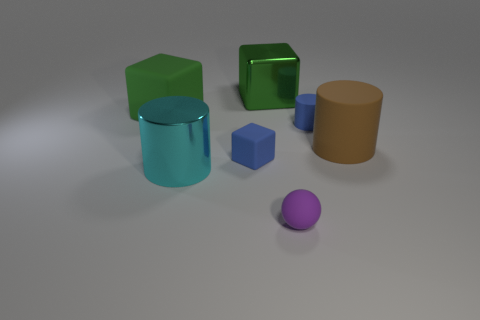Does the small matte block have the same color as the small cylinder?
Keep it short and to the point. Yes. Are there any brown objects of the same shape as the big cyan metal object?
Your answer should be very brief. Yes. How many big gray cubes have the same material as the tiny cube?
Offer a very short reply. 0. Do the object to the right of the blue cylinder and the purple object have the same material?
Your answer should be very brief. Yes. Are there more blocks behind the green matte thing than big green cubes that are right of the purple thing?
Give a very brief answer. Yes. What is the material of the cyan object that is the same size as the metallic block?
Give a very brief answer. Metal. What number of other things are there of the same material as the tiny sphere
Ensure brevity in your answer.  4. Do the tiny blue thing that is on the left side of the metallic block and the green thing that is to the left of the green shiny object have the same shape?
Make the answer very short. Yes. How many other things are there of the same color as the large metallic block?
Make the answer very short. 1. Is the large object right of the purple rubber sphere made of the same material as the small blue thing that is behind the large brown cylinder?
Make the answer very short. Yes. 